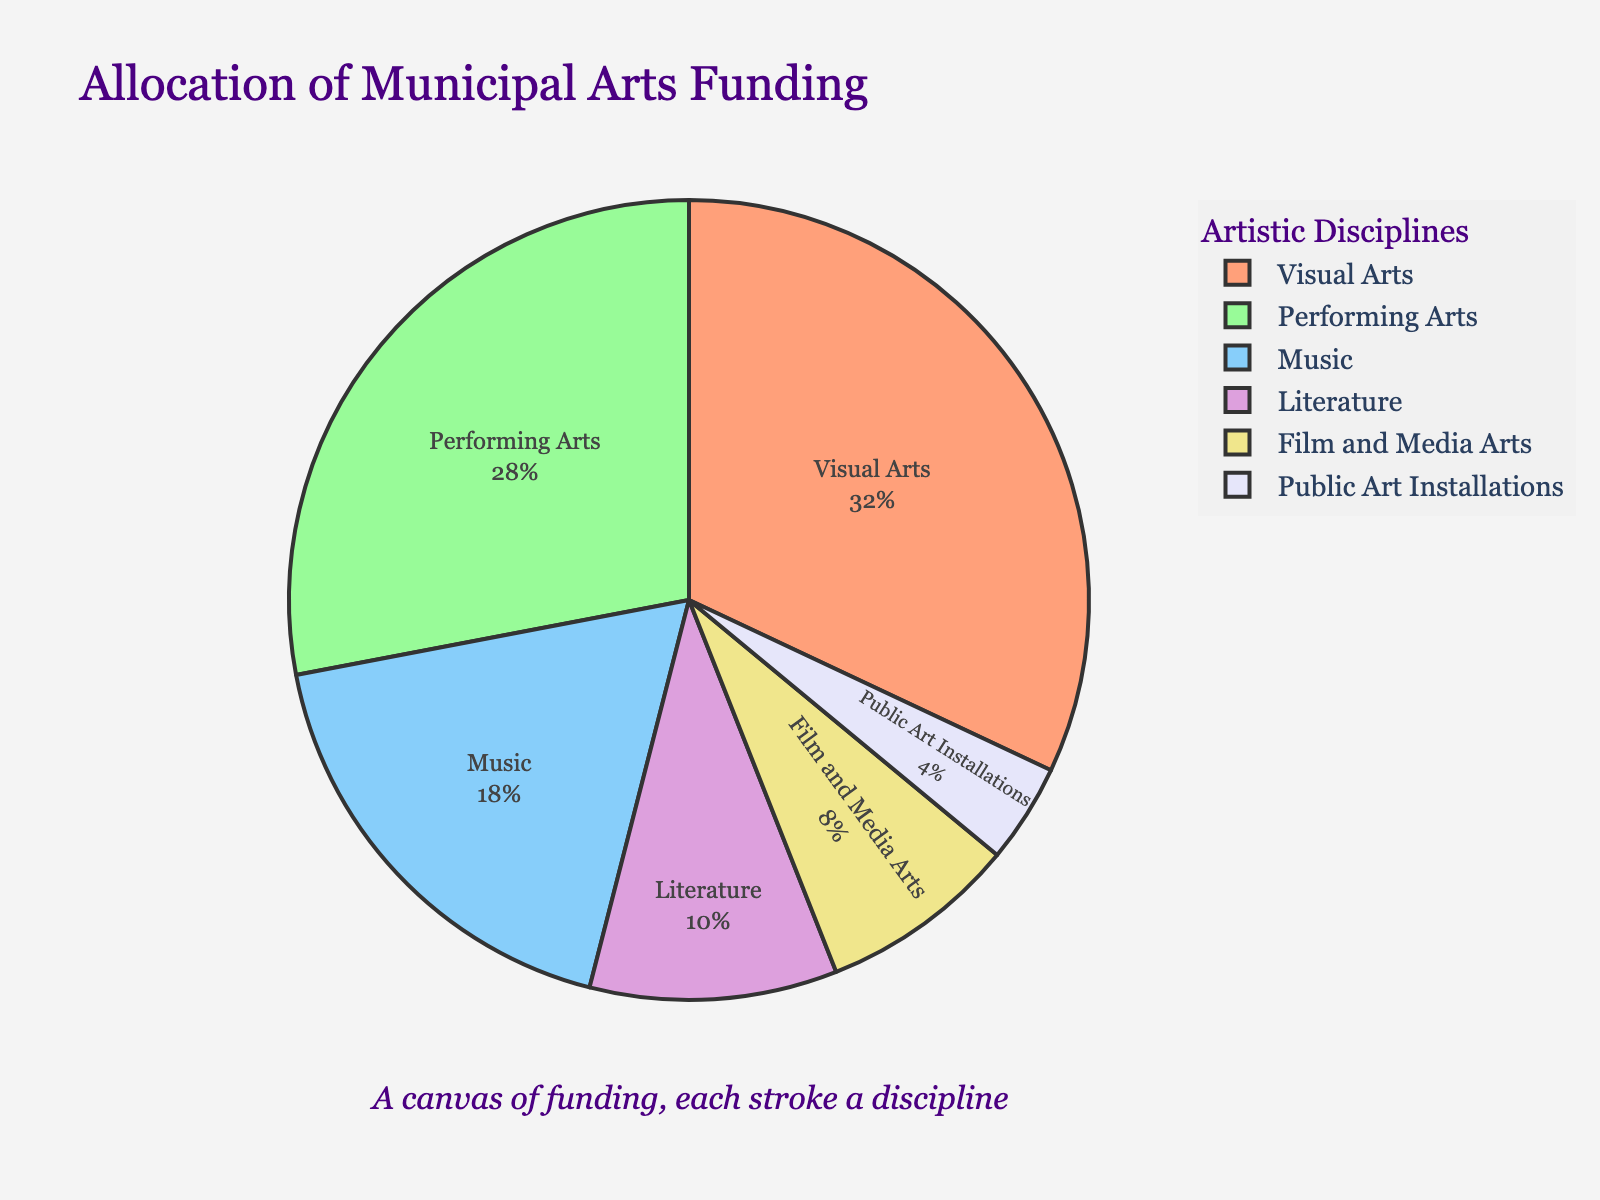What percentage of the funding is allocated to Performing Arts and Literature combined? Add the percentages for Performing Arts (28%) and Literature (10%). So, 28% + 10% = 38%.
Answer: 38% Which artistic discipline receives the least funding? Identify the discipline with the smallest segment in the pie chart. Public Art Installations receive the least funding at 4%.
Answer: Public Art Installations Is the funding for Visual Arts greater than the combined funding for Music, Literature, and Film and Media Arts? Compare the funding percent for Visual Arts (32%) with the sum of funding for Music (18%), Literature (10%), and Film and Media Arts (8%). The sum is 18% + 10% + 8% = 36%, which is greater than Visual Arts (32%).
Answer: No What is the difference in funding allocation between Visual Arts and Music? Calculate the difference between the percentage allocations: Visual Arts (32%) and Music (18%). So, 32% - 18% = 14%.
Answer: 14% How does the funding for Visual Arts compare to Performing Arts? Compare the percentage allocations: Visual Arts (32%) is larger than Performing Arts (28%).
Answer: Visual Arts has more funding than Performing Arts What percentage of funding lies outside of Visual Arts and Performing Arts? Calculate the total funding excluding Visual Arts (32%) and Performing Arts (28%): 100% - 32% - 28% = 40%.
Answer: 40% List all disciplines that receive less than 10% of the total funding. Identify the disciplines with allocations less than 10%: Literature (10%), Film and Media Arts (8%), and Public Art Installations (4%). Drilling down to strictly less than 10%, the disciplines are Film and Media Arts (8%) and Public Art Installations (4%).
Answer: Film and Media Arts, Public Art Installations Which two disciplines have the smallest funding differences between them, and what is the difference? Look at the percentage differences: Film and Media Arts (8%) and Literature (10%) have a small difference. Difference is 10% - 8% = 2%.
Answer: Film and Media Arts and Literature, 2% 